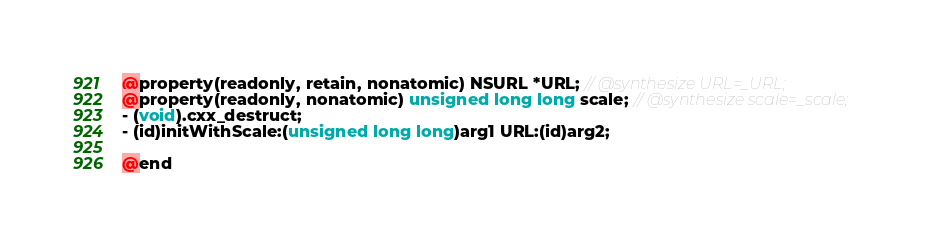Convert code to text. <code><loc_0><loc_0><loc_500><loc_500><_C_>@property(readonly, retain, nonatomic) NSURL *URL; // @synthesize URL=_URL;
@property(readonly, nonatomic) unsigned long long scale; // @synthesize scale=_scale;
- (void).cxx_destruct;
- (id)initWithScale:(unsigned long long)arg1 URL:(id)arg2;

@end

</code> 